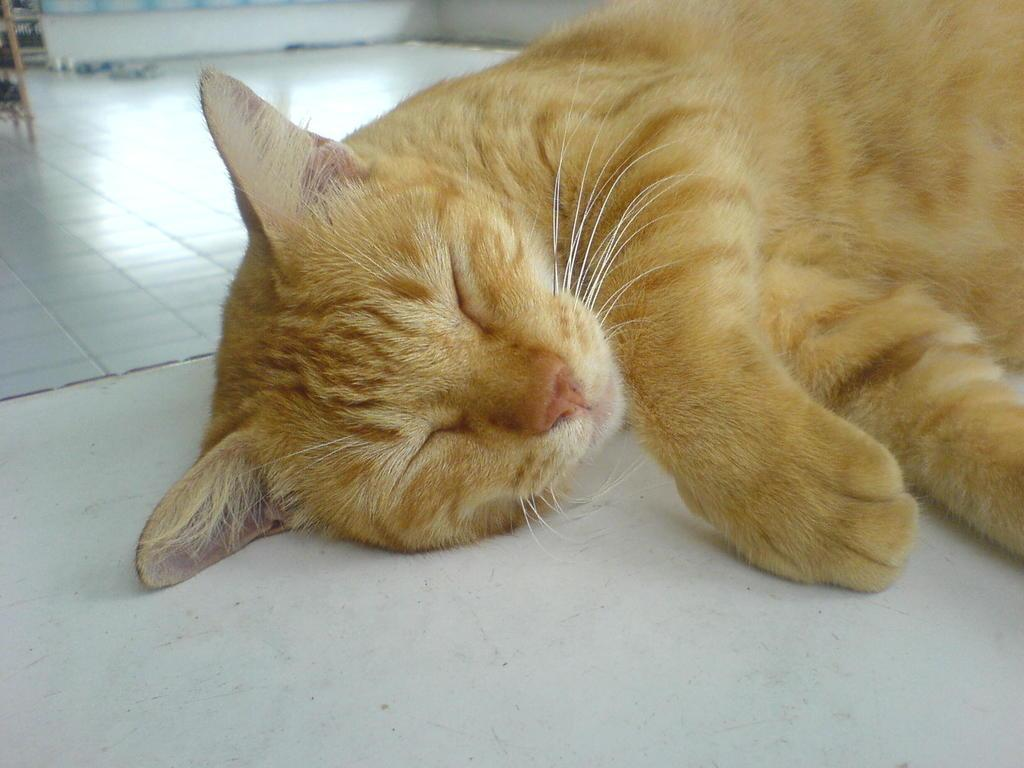What type of animal is in the image? There is a brown cat in the image. What is the cat doing in the image? The cat is lying on the floor. What type of chicken is present in the image? There is no chicken present in the image; it features a brown cat lying on the floor. What amusement park can be seen in the background of the image? There is no amusement park visible in the image; it only shows a brown cat lying on the floor. 